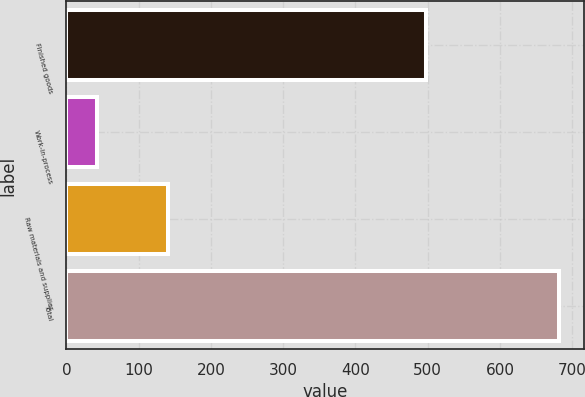<chart> <loc_0><loc_0><loc_500><loc_500><bar_chart><fcel>Finished goods<fcel>Work-in-process<fcel>Raw materials and supplies<fcel>Total<nl><fcel>498<fcel>43<fcel>141<fcel>682<nl></chart> 